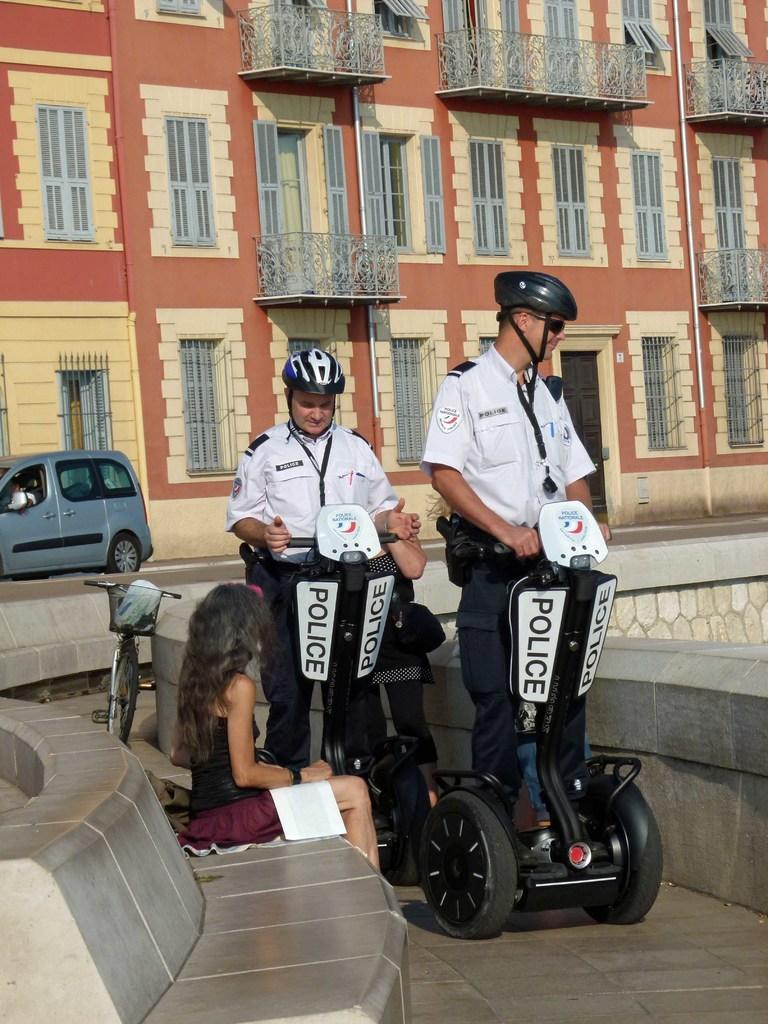What are the two men doing in the image? The two men are riding on a vehicle in the street. What is the woman doing in the image? The woman is sitting on a chair. What can be seen behind the people in the image? There is a building behind the people. What else is present on the road in the image? There is a car on the road. What type of toys can be seen in the image? There are no toys present in the image. 